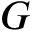<formula> <loc_0><loc_0><loc_500><loc_500>G</formula> 